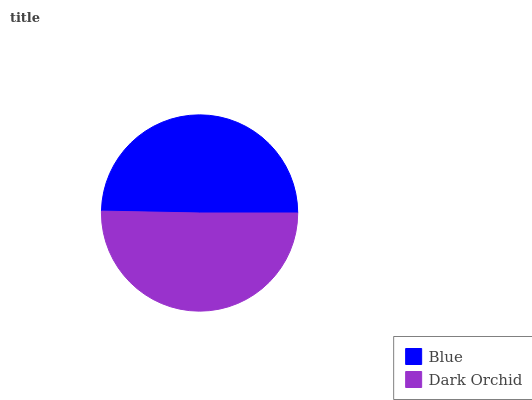Is Blue the minimum?
Answer yes or no. Yes. Is Dark Orchid the maximum?
Answer yes or no. Yes. Is Dark Orchid the minimum?
Answer yes or no. No. Is Dark Orchid greater than Blue?
Answer yes or no. Yes. Is Blue less than Dark Orchid?
Answer yes or no. Yes. Is Blue greater than Dark Orchid?
Answer yes or no. No. Is Dark Orchid less than Blue?
Answer yes or no. No. Is Dark Orchid the high median?
Answer yes or no. Yes. Is Blue the low median?
Answer yes or no. Yes. Is Blue the high median?
Answer yes or no. No. Is Dark Orchid the low median?
Answer yes or no. No. 